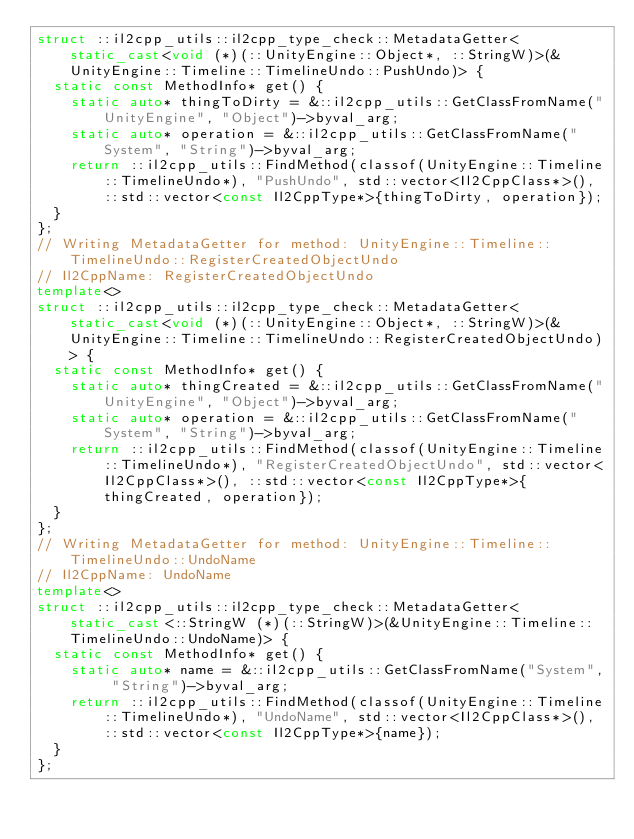<code> <loc_0><loc_0><loc_500><loc_500><_C++_>struct ::il2cpp_utils::il2cpp_type_check::MetadataGetter<static_cast<void (*)(::UnityEngine::Object*, ::StringW)>(&UnityEngine::Timeline::TimelineUndo::PushUndo)> {
  static const MethodInfo* get() {
    static auto* thingToDirty = &::il2cpp_utils::GetClassFromName("UnityEngine", "Object")->byval_arg;
    static auto* operation = &::il2cpp_utils::GetClassFromName("System", "String")->byval_arg;
    return ::il2cpp_utils::FindMethod(classof(UnityEngine::Timeline::TimelineUndo*), "PushUndo", std::vector<Il2CppClass*>(), ::std::vector<const Il2CppType*>{thingToDirty, operation});
  }
};
// Writing MetadataGetter for method: UnityEngine::Timeline::TimelineUndo::RegisterCreatedObjectUndo
// Il2CppName: RegisterCreatedObjectUndo
template<>
struct ::il2cpp_utils::il2cpp_type_check::MetadataGetter<static_cast<void (*)(::UnityEngine::Object*, ::StringW)>(&UnityEngine::Timeline::TimelineUndo::RegisterCreatedObjectUndo)> {
  static const MethodInfo* get() {
    static auto* thingCreated = &::il2cpp_utils::GetClassFromName("UnityEngine", "Object")->byval_arg;
    static auto* operation = &::il2cpp_utils::GetClassFromName("System", "String")->byval_arg;
    return ::il2cpp_utils::FindMethod(classof(UnityEngine::Timeline::TimelineUndo*), "RegisterCreatedObjectUndo", std::vector<Il2CppClass*>(), ::std::vector<const Il2CppType*>{thingCreated, operation});
  }
};
// Writing MetadataGetter for method: UnityEngine::Timeline::TimelineUndo::UndoName
// Il2CppName: UndoName
template<>
struct ::il2cpp_utils::il2cpp_type_check::MetadataGetter<static_cast<::StringW (*)(::StringW)>(&UnityEngine::Timeline::TimelineUndo::UndoName)> {
  static const MethodInfo* get() {
    static auto* name = &::il2cpp_utils::GetClassFromName("System", "String")->byval_arg;
    return ::il2cpp_utils::FindMethod(classof(UnityEngine::Timeline::TimelineUndo*), "UndoName", std::vector<Il2CppClass*>(), ::std::vector<const Il2CppType*>{name});
  }
};
</code> 